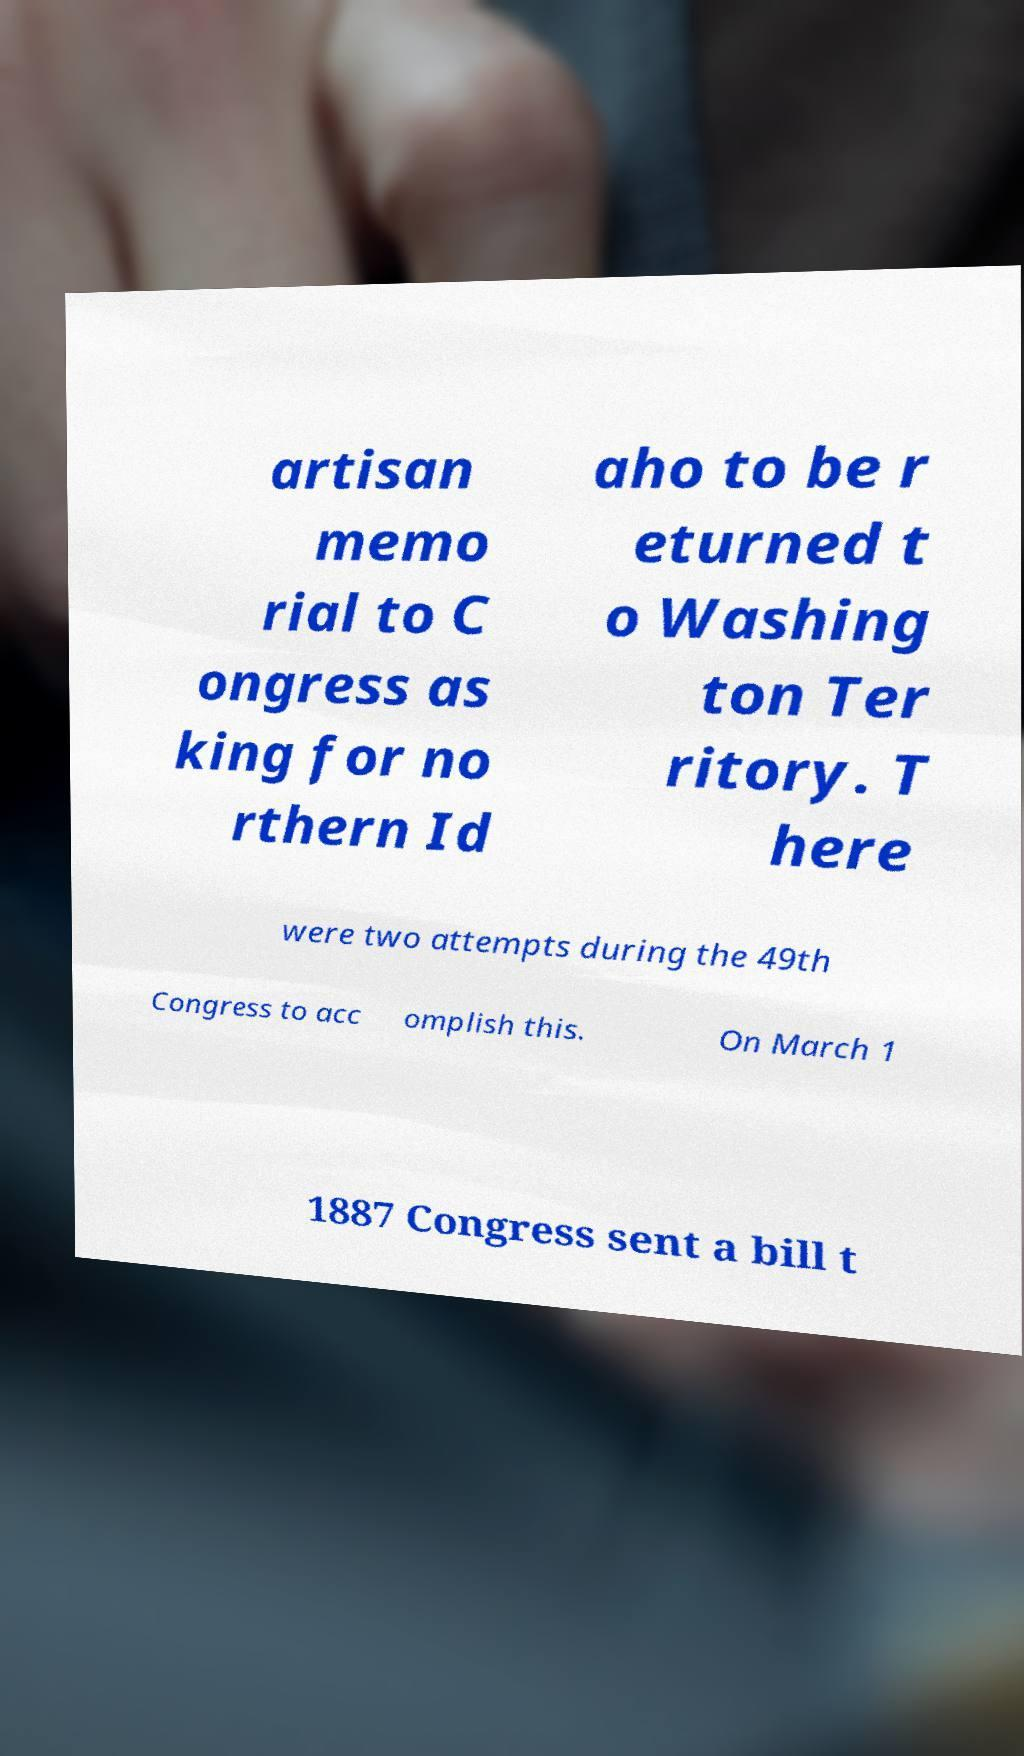Could you extract and type out the text from this image? artisan memo rial to C ongress as king for no rthern Id aho to be r eturned t o Washing ton Ter ritory. T here were two attempts during the 49th Congress to acc omplish this. On March 1 1887 Congress sent a bill t 